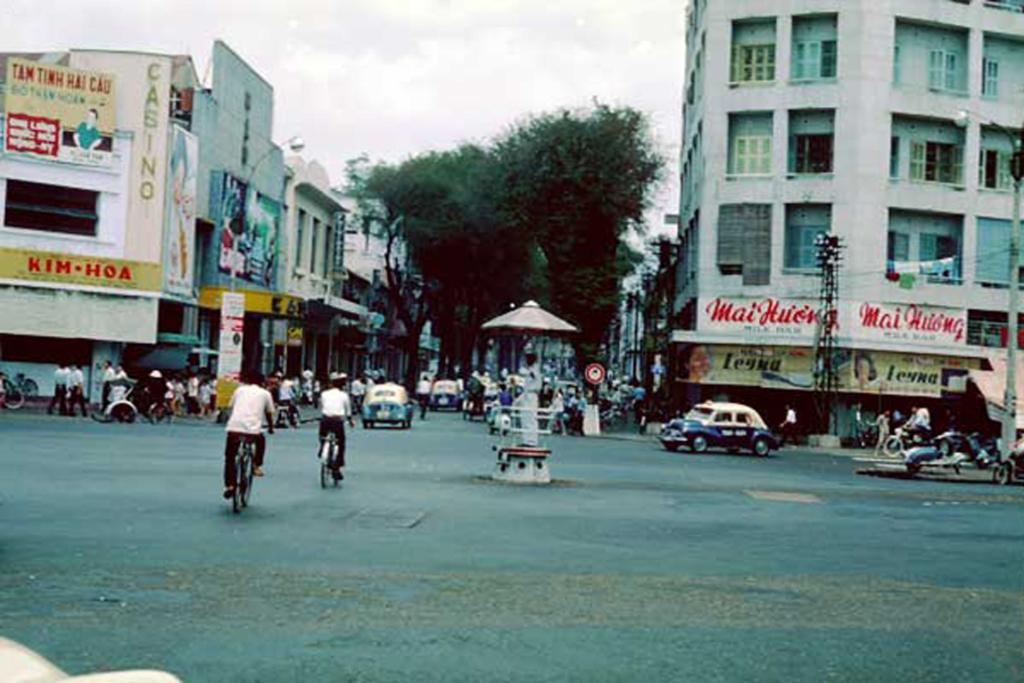What types of transportation can be seen in the image? There are vehicles in the image. What are some people doing in the image? Some people are riding bicycles on the road. What features can be observed on the buildings in the image? The buildings have windows. What additional decorative elements are present in the image? Banners are present in the image. What type of natural vegetation is visible in the image? Trees are visible in the image. What is visible in the background of the image? The sky is visible in the background of the image. What type of pest can be seen crawling on the banners in the image? There are no pests visible on the banners in the image. 